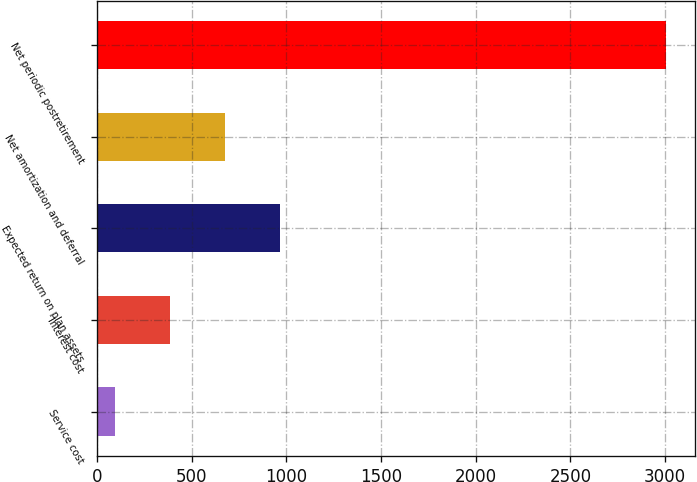Convert chart. <chart><loc_0><loc_0><loc_500><loc_500><bar_chart><fcel>Service cost<fcel>Interest cost<fcel>Expected return on plan assets<fcel>Net amortization and deferral<fcel>Net periodic postretirement<nl><fcel>93<fcel>384.4<fcel>967.2<fcel>675.8<fcel>3007<nl></chart> 